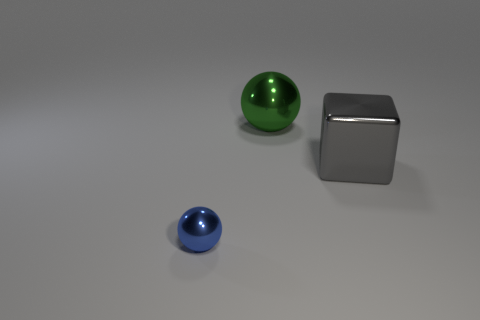Is the size of the metallic thing behind the gray shiny cube the same as the gray cube?
Give a very brief answer. Yes. There is a metal sphere right of the blue shiny sphere; are there any shiny balls that are to the left of it?
Keep it short and to the point. Yes. Is there a gray cube that has the same material as the green thing?
Offer a terse response. Yes. What material is the ball in front of the metal sphere behind the metallic block?
Offer a terse response. Metal. There is a thing that is to the left of the cube and on the right side of the tiny blue shiny thing; what is it made of?
Keep it short and to the point. Metal. Is the number of green shiny things behind the small blue thing the same as the number of small metallic balls?
Provide a short and direct response. Yes. How many small blue things are the same shape as the green metal thing?
Offer a terse response. 1. What is the size of the metallic thing right of the shiny ball behind the big thing in front of the large metallic ball?
Provide a short and direct response. Large. Does the object that is left of the large metal sphere have the same material as the gray cube?
Make the answer very short. Yes. Is the number of green shiny balls to the left of the tiny shiny ball the same as the number of tiny metal things right of the big block?
Ensure brevity in your answer.  Yes. 